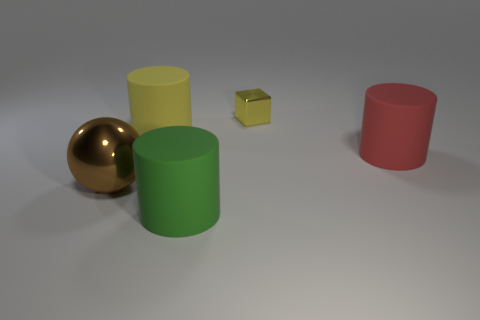Subtract all big yellow matte cylinders. How many cylinders are left? 2 Subtract 1 cylinders. How many cylinders are left? 2 Add 3 yellow things. How many objects exist? 8 Subtract all cubes. How many objects are left? 4 Subtract 0 green blocks. How many objects are left? 5 Subtract all purple metallic cubes. Subtract all green matte cylinders. How many objects are left? 4 Add 2 shiny blocks. How many shiny blocks are left? 3 Add 1 metal balls. How many metal balls exist? 2 